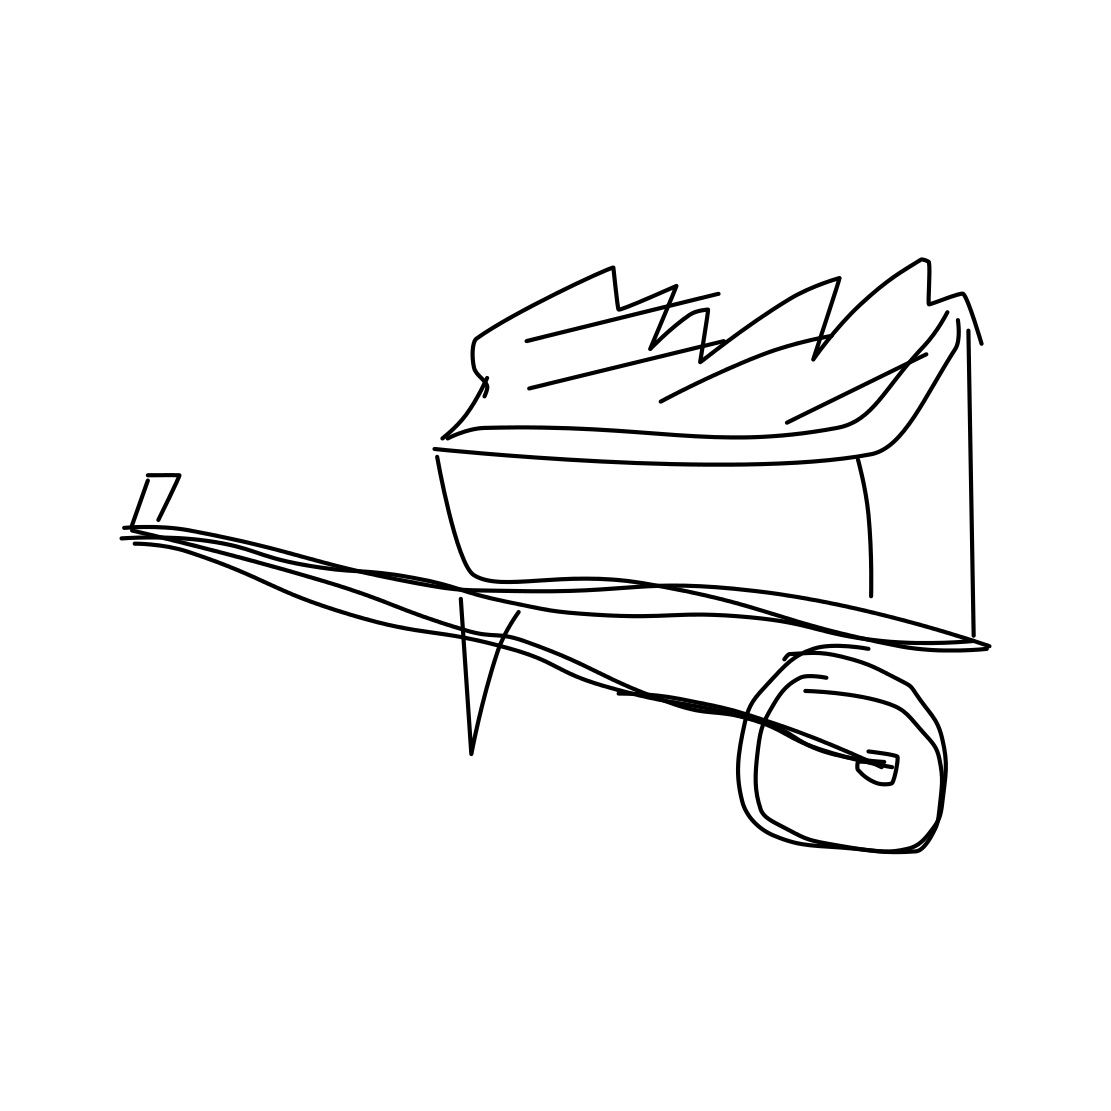What kind of object is shown in the image, and how does it appear to be used? The image shows a wheeled bin, typically used for holding refuse. It appears to be overflowing, suggesting it is heavily used or not emptied frequently. Is there anything peculiar about how the objects are drawn? Yes, the style is quite minimal and abstract, with very basic lines used to form the objects without much detail or realism. This artistic choice gives the image a unique, almost cartoon-like appearance. 